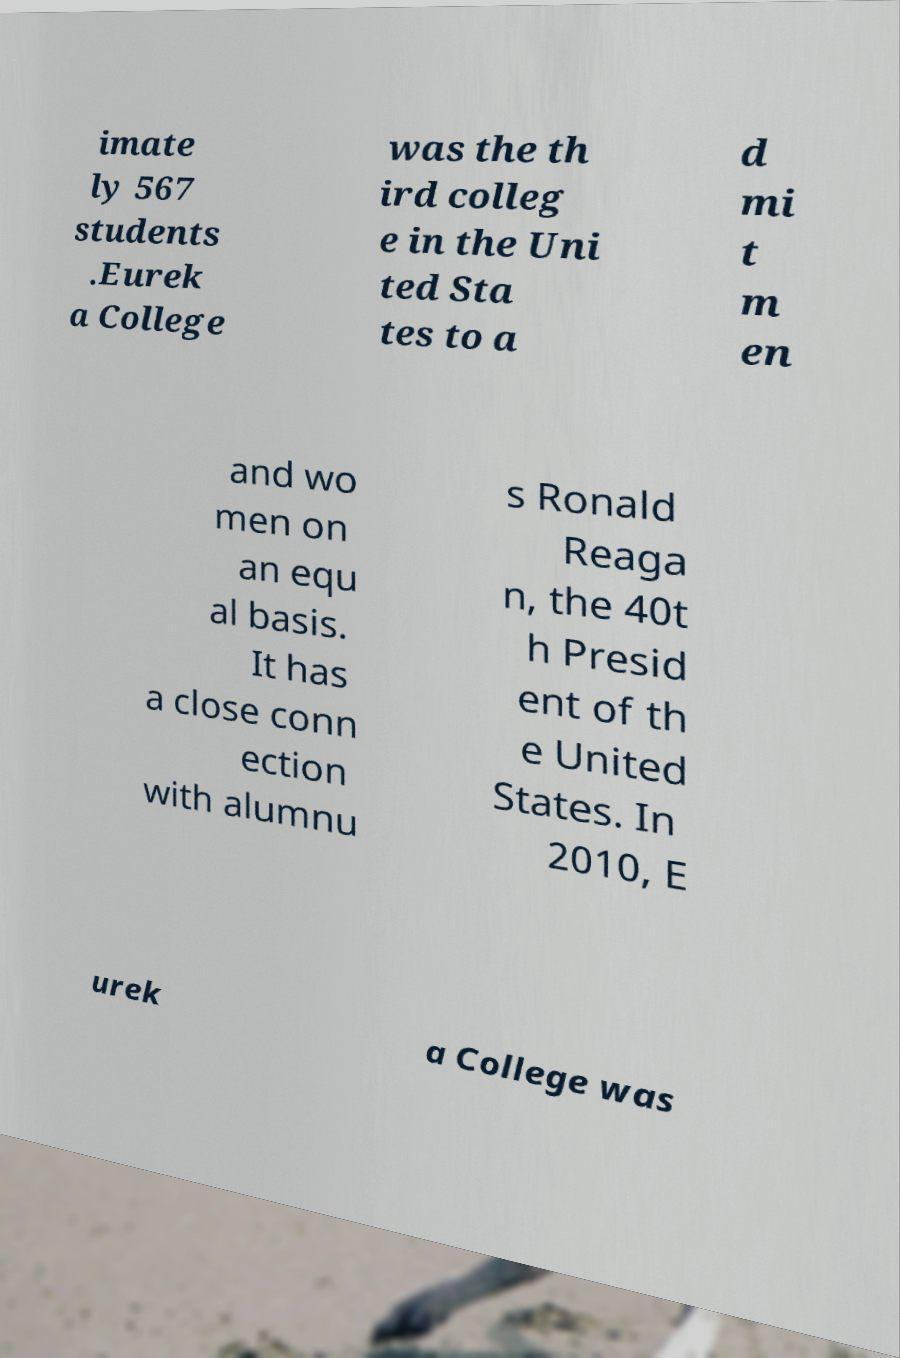Can you read and provide the text displayed in the image?This photo seems to have some interesting text. Can you extract and type it out for me? imate ly 567 students .Eurek a College was the th ird colleg e in the Uni ted Sta tes to a d mi t m en and wo men on an equ al basis. It has a close conn ection with alumnu s Ronald Reaga n, the 40t h Presid ent of th e United States. In 2010, E urek a College was 